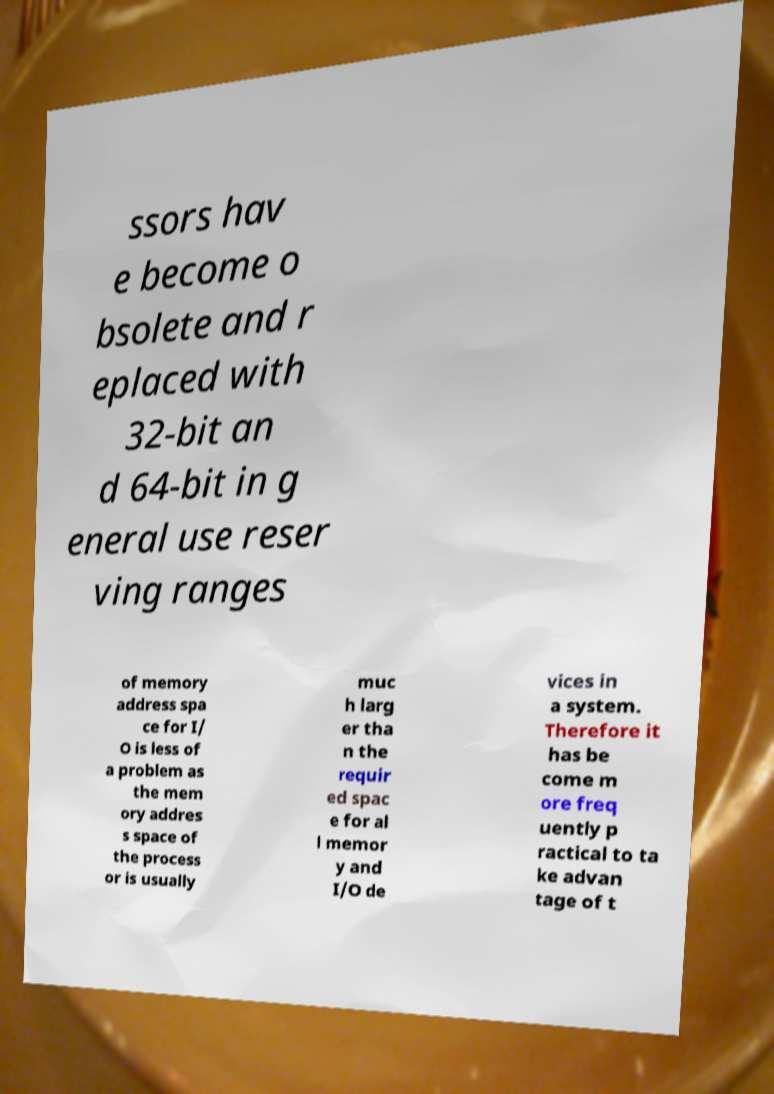Can you accurately transcribe the text from the provided image for me? ssors hav e become o bsolete and r eplaced with 32-bit an d 64-bit in g eneral use reser ving ranges of memory address spa ce for I/ O is less of a problem as the mem ory addres s space of the process or is usually muc h larg er tha n the requir ed spac e for al l memor y and I/O de vices in a system. Therefore it has be come m ore freq uently p ractical to ta ke advan tage of t 